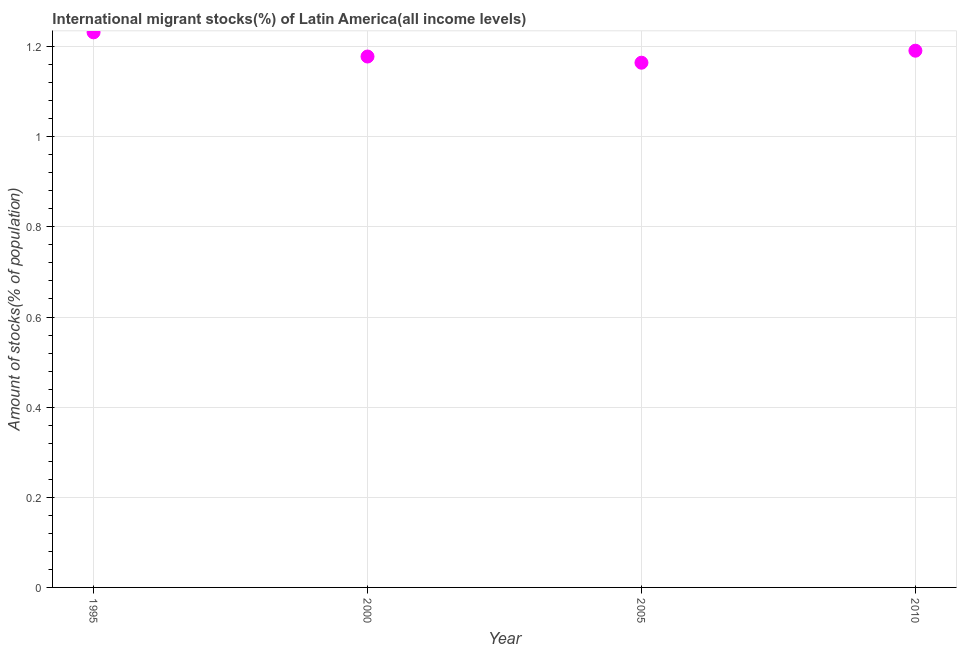What is the number of international migrant stocks in 2010?
Offer a very short reply. 1.19. Across all years, what is the maximum number of international migrant stocks?
Provide a succinct answer. 1.23. Across all years, what is the minimum number of international migrant stocks?
Offer a very short reply. 1.16. What is the sum of the number of international migrant stocks?
Provide a succinct answer. 4.76. What is the difference between the number of international migrant stocks in 2000 and 2005?
Keep it short and to the point. 0.01. What is the average number of international migrant stocks per year?
Offer a terse response. 1.19. What is the median number of international migrant stocks?
Offer a terse response. 1.18. In how many years, is the number of international migrant stocks greater than 0.36 %?
Ensure brevity in your answer.  4. What is the ratio of the number of international migrant stocks in 2005 to that in 2010?
Offer a very short reply. 0.98. What is the difference between the highest and the second highest number of international migrant stocks?
Offer a terse response. 0.04. What is the difference between the highest and the lowest number of international migrant stocks?
Ensure brevity in your answer.  0.07. Does the number of international migrant stocks monotonically increase over the years?
Give a very brief answer. No. How many dotlines are there?
Your answer should be compact. 1. How many years are there in the graph?
Offer a terse response. 4. Does the graph contain grids?
Your answer should be very brief. Yes. What is the title of the graph?
Give a very brief answer. International migrant stocks(%) of Latin America(all income levels). What is the label or title of the X-axis?
Ensure brevity in your answer.  Year. What is the label or title of the Y-axis?
Ensure brevity in your answer.  Amount of stocks(% of population). What is the Amount of stocks(% of population) in 1995?
Your answer should be very brief. 1.23. What is the Amount of stocks(% of population) in 2000?
Offer a terse response. 1.18. What is the Amount of stocks(% of population) in 2005?
Provide a short and direct response. 1.16. What is the Amount of stocks(% of population) in 2010?
Ensure brevity in your answer.  1.19. What is the difference between the Amount of stocks(% of population) in 1995 and 2000?
Provide a succinct answer. 0.05. What is the difference between the Amount of stocks(% of population) in 1995 and 2005?
Keep it short and to the point. 0.07. What is the difference between the Amount of stocks(% of population) in 1995 and 2010?
Your response must be concise. 0.04. What is the difference between the Amount of stocks(% of population) in 2000 and 2005?
Ensure brevity in your answer.  0.01. What is the difference between the Amount of stocks(% of population) in 2000 and 2010?
Give a very brief answer. -0.01. What is the difference between the Amount of stocks(% of population) in 2005 and 2010?
Ensure brevity in your answer.  -0.03. What is the ratio of the Amount of stocks(% of population) in 1995 to that in 2000?
Your answer should be very brief. 1.05. What is the ratio of the Amount of stocks(% of population) in 1995 to that in 2005?
Offer a terse response. 1.06. What is the ratio of the Amount of stocks(% of population) in 1995 to that in 2010?
Give a very brief answer. 1.03. What is the ratio of the Amount of stocks(% of population) in 2005 to that in 2010?
Keep it short and to the point. 0.98. 